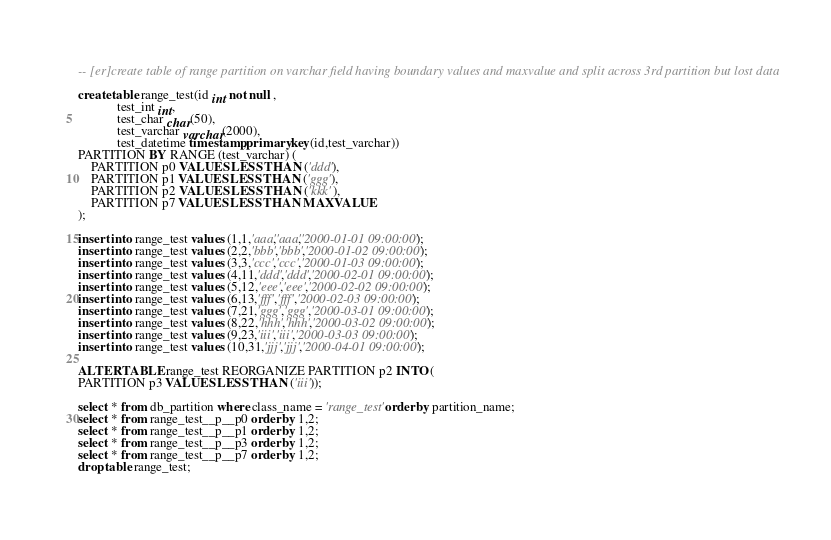<code> <loc_0><loc_0><loc_500><loc_500><_SQL_>-- [er]create table of range partition on varchar field having boundary values and maxvalue and split across 3rd partition but lost data

create table range_test(id int not null ,
			test_int int,
			test_char char(50),
			test_varchar varchar(2000),
			test_datetime timestamp,primary key(id,test_varchar))
PARTITION BY RANGE (test_varchar) (
    PARTITION p0 VALUES LESS THAN ('ddd'),
    PARTITION p1 VALUES LESS THAN ('ggg'),
    PARTITION p2 VALUES LESS THAN ('kkk'),
    PARTITION p7 VALUES LESS THAN MAXVALUE
);

insert into range_test values (1,1,'aaa','aaa','2000-01-01 09:00:00');
insert into range_test values (2,2,'bbb','bbb','2000-01-02 09:00:00');
insert into range_test values (3,3,'ccc','ccc','2000-01-03 09:00:00');
insert into range_test values (4,11,'ddd','ddd','2000-02-01 09:00:00');
insert into range_test values (5,12,'eee','eee','2000-02-02 09:00:00');
insert into range_test values (6,13,'fff','fff','2000-02-03 09:00:00');
insert into range_test values (7,21,'ggg','ggg','2000-03-01 09:00:00');
insert into range_test values (8,22,'hhh','hhh','2000-03-02 09:00:00');
insert into range_test values (9,23,'iii','iii','2000-03-03 09:00:00');
insert into range_test values (10,31,'jjj','jjj','2000-04-01 09:00:00');

ALTER TABLE range_test REORGANIZE PARTITION p2 INTO ( 
PARTITION p3 VALUES LESS THAN ('iii'));

select * from db_partition where class_name = 'range_test' order by partition_name;
select * from range_test__p__p0 order by 1,2;
select * from range_test__p__p1 order by 1,2;
select * from range_test__p__p3 order by 1,2;
select * from range_test__p__p7 order by 1,2;
drop table range_test;
</code> 